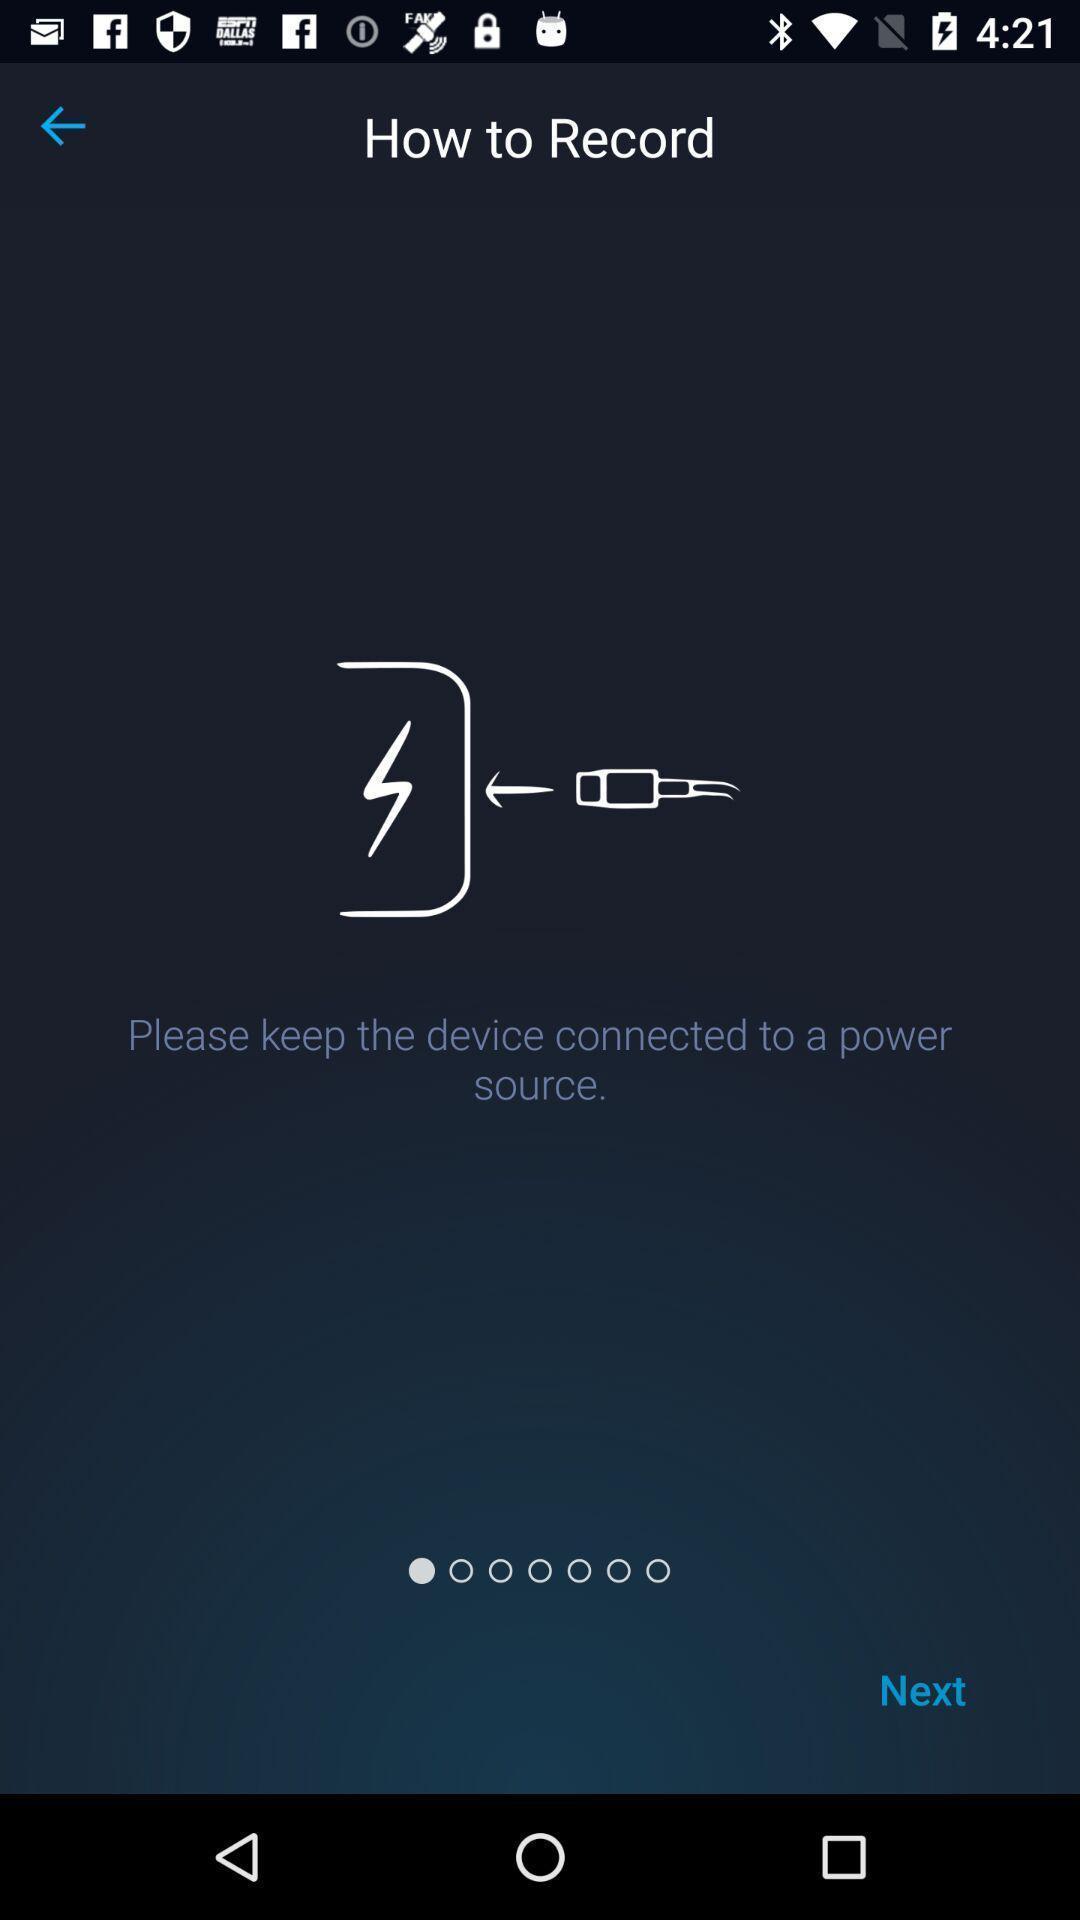Summarize the information in this screenshot. Page showing steps to record. 